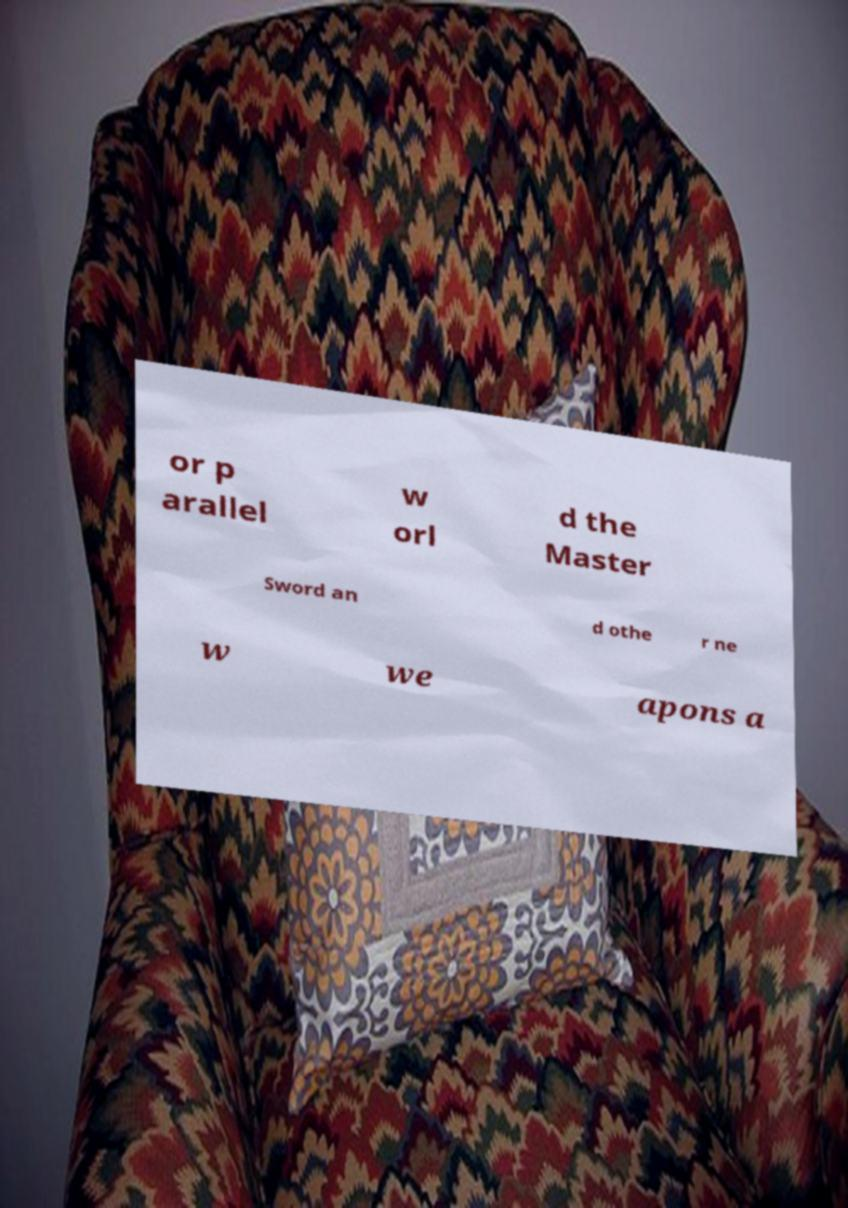There's text embedded in this image that I need extracted. Can you transcribe it verbatim? or p arallel w orl d the Master Sword an d othe r ne w we apons a 